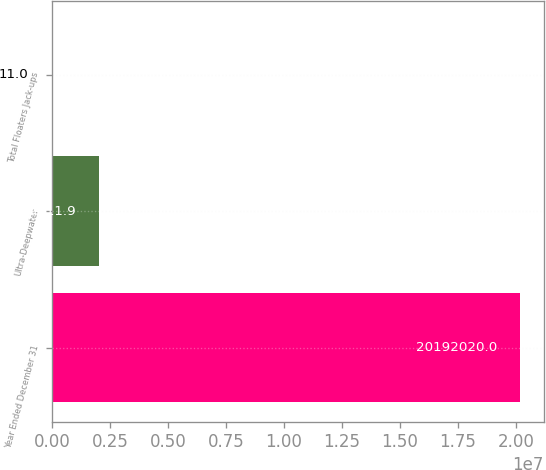<chart> <loc_0><loc_0><loc_500><loc_500><bar_chart><fcel>Year Ended December 31<fcel>Ultra-Deepwater<fcel>Total Floaters Jack-ups<nl><fcel>2.0192e+07<fcel>2.01921e+06<fcel>11<nl></chart> 